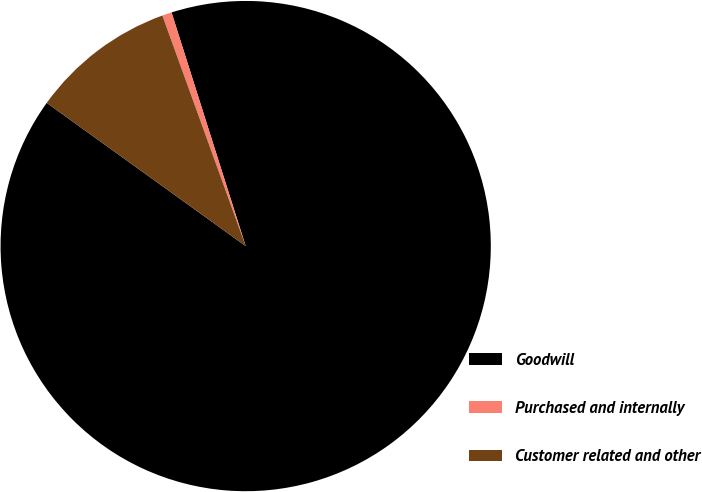<chart> <loc_0><loc_0><loc_500><loc_500><pie_chart><fcel>Goodwill<fcel>Purchased and internally<fcel>Customer related and other<nl><fcel>89.83%<fcel>0.63%<fcel>9.55%<nl></chart> 